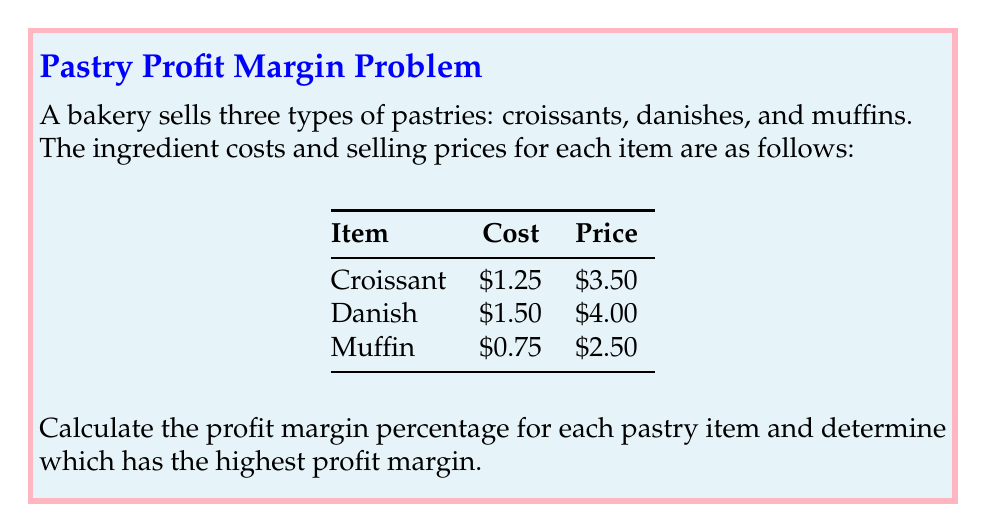Help me with this question. To solve this problem, we'll follow these steps for each pastry item:

1. Calculate the profit per item
2. Calculate the profit margin percentage
3. Compare the profit margins

Let's start with each pastry:

1. Croissant:
   Profit = Selling Price - Cost
   $$ \text{Profit} = \$3.50 - \$1.25 = \$2.25 $$
   Profit Margin % = (Profit / Selling Price) × 100%
   $$ \text{Profit Margin \%} = \frac{\$2.25}{\$3.50} \times 100\% = 64.29\% $$

2. Danish:
   Profit = $4.00 - $1.50 = $2.50
   $$ \text{Profit Margin \%} = \frac{\$2.50}{\$4.00} \times 100\% = 62.50\% $$

3. Muffin:
   Profit = $2.50 - $0.75 = $1.75
   $$ \text{Profit Margin \%} = \frac{\$1.75}{\$2.50} \times 100\% = 70.00\% $$

Comparing the profit margins:
Croissant: 64.29%
Danish: 62.50%
Muffin: 70.00%

The muffin has the highest profit margin at 70.00%.
Answer: Muffin: 70.00% 